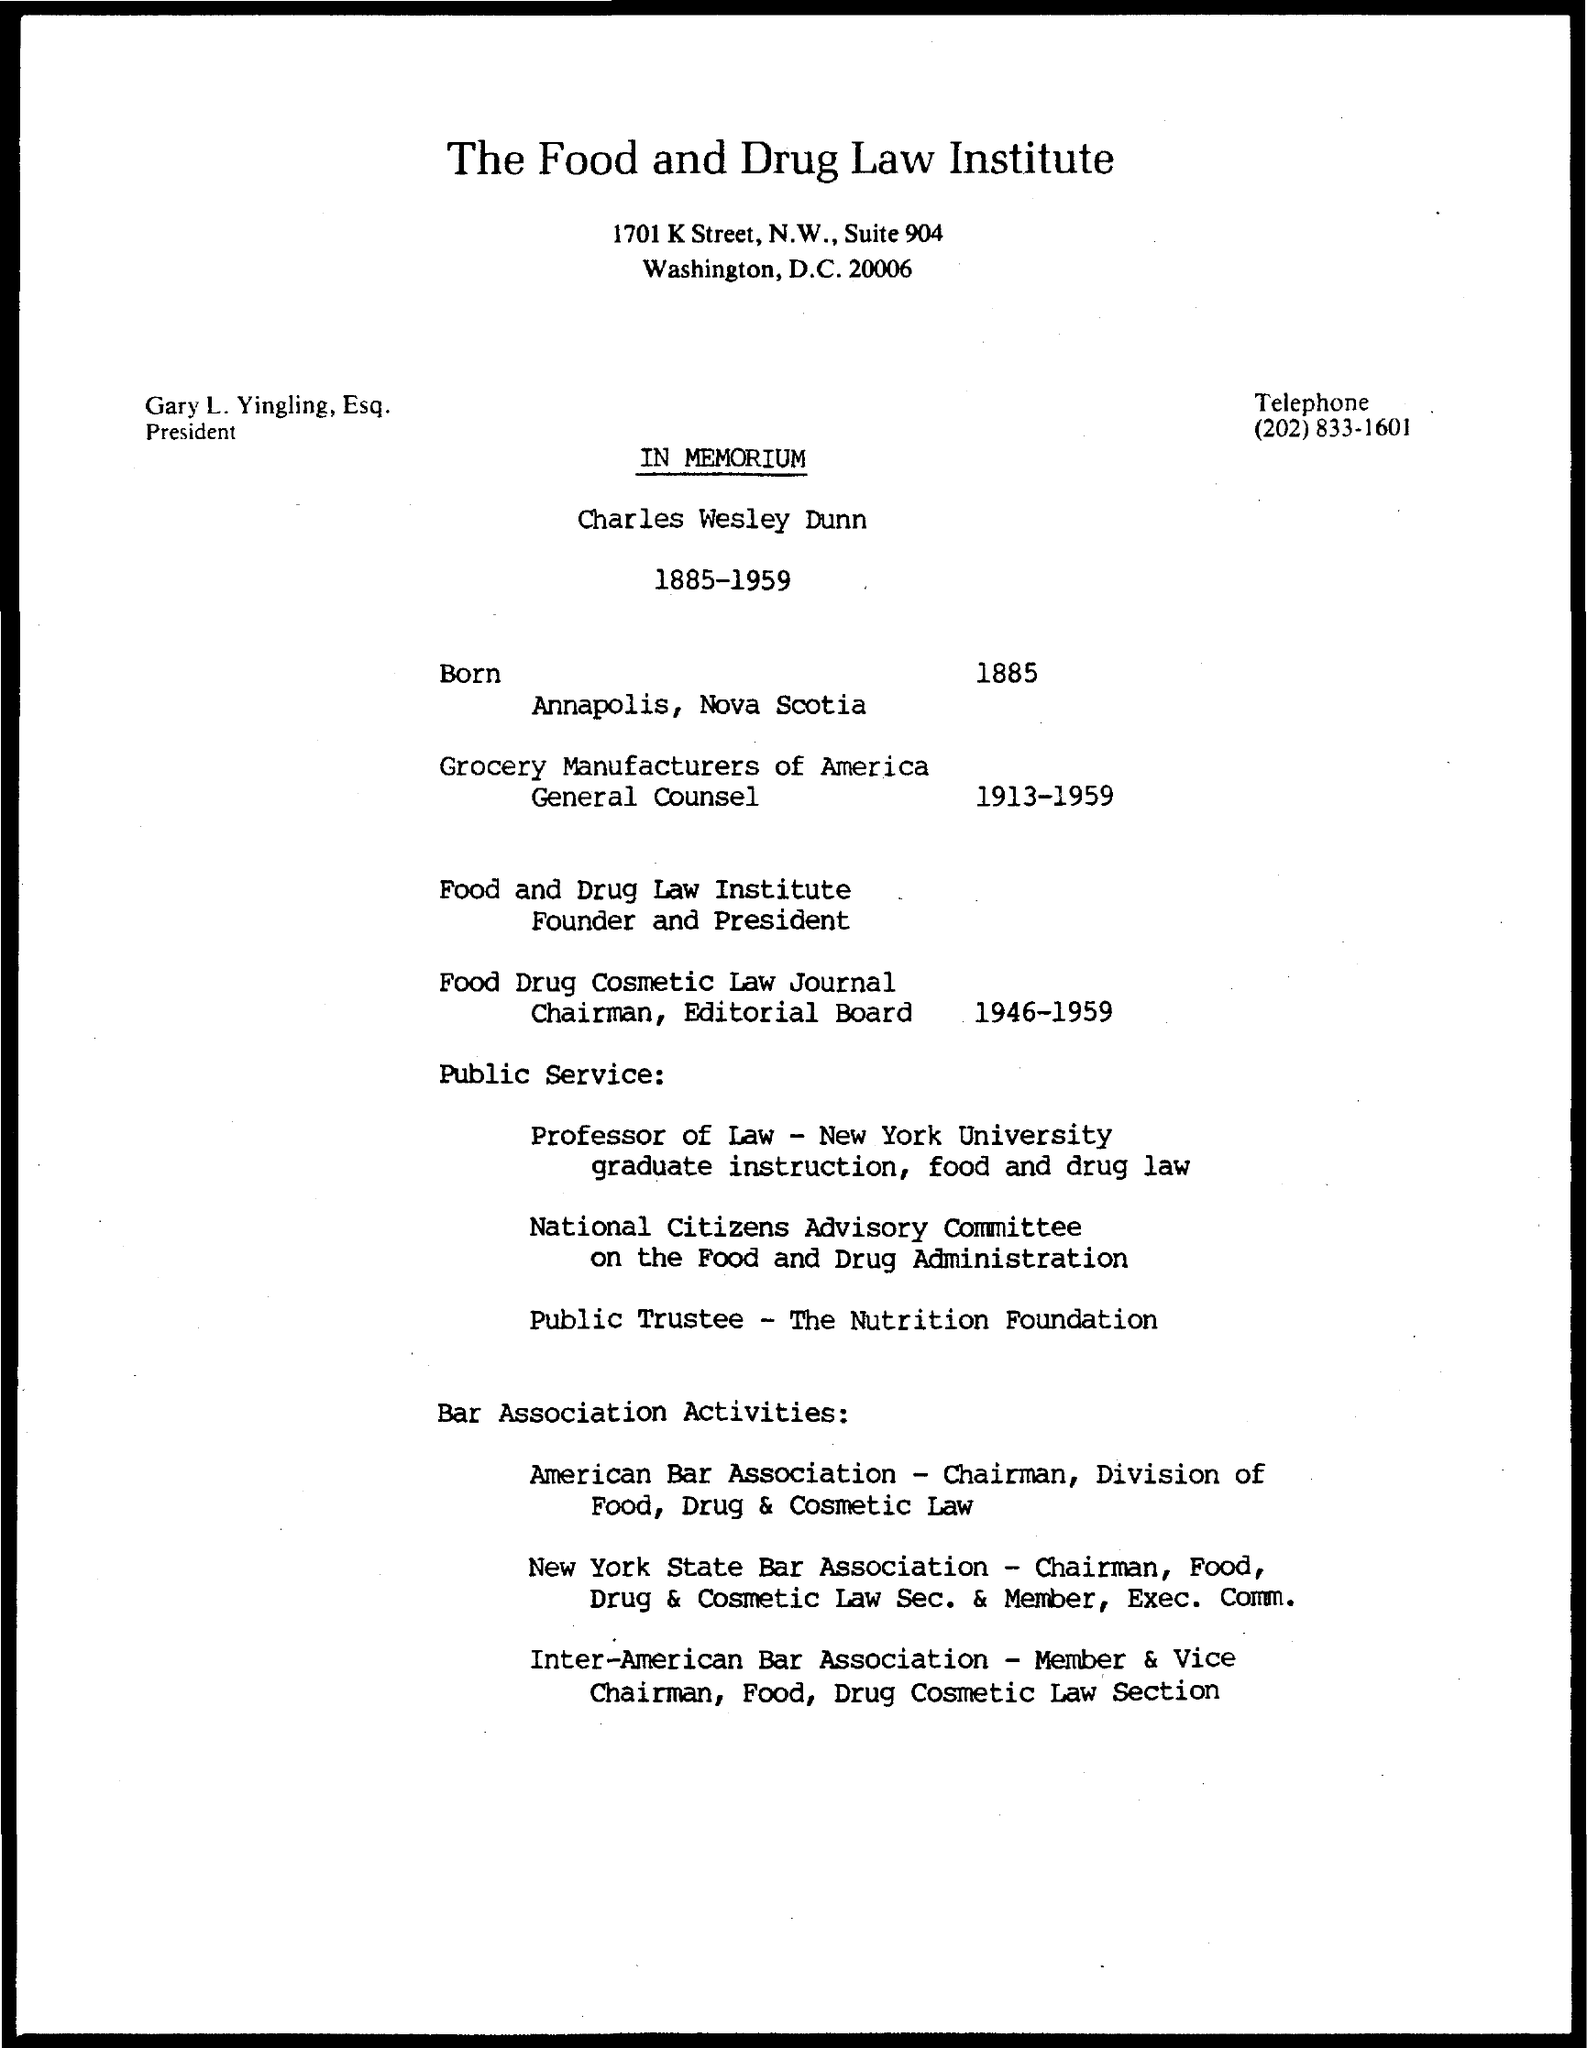What is the title of the document?
Ensure brevity in your answer.  The food and drug law institute. What is the telephone number mentioned in the document?
Give a very brief answer. (202) 833-1601. 